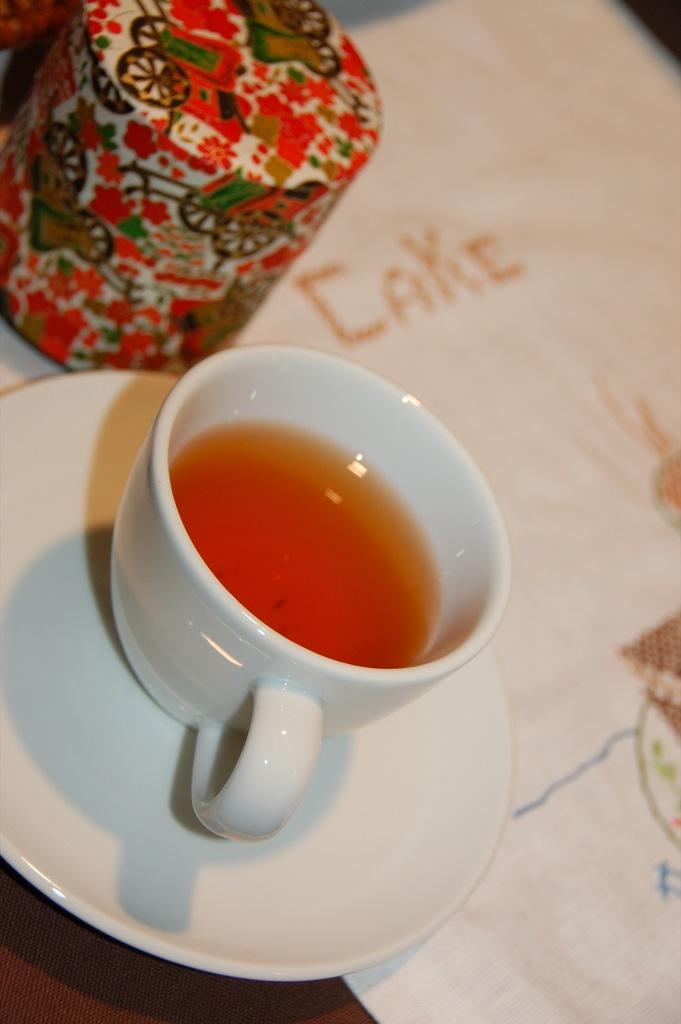What piece of furniture is present in the image? There is a table in the image. What is placed on the table? There is a pet jar, a tablecloth, a cup, and a saucer on the table. What might be used to cover the table in the image? The tablecloth is used to cover the table in the image. What is the purpose of the saucer on the table? The saucer is likely used to hold the cup in place or to catch any spills. Where is the queen sitting in the image? There is no queen present in the image. How many horses can be seen in the image? There are no horses present in the image. 